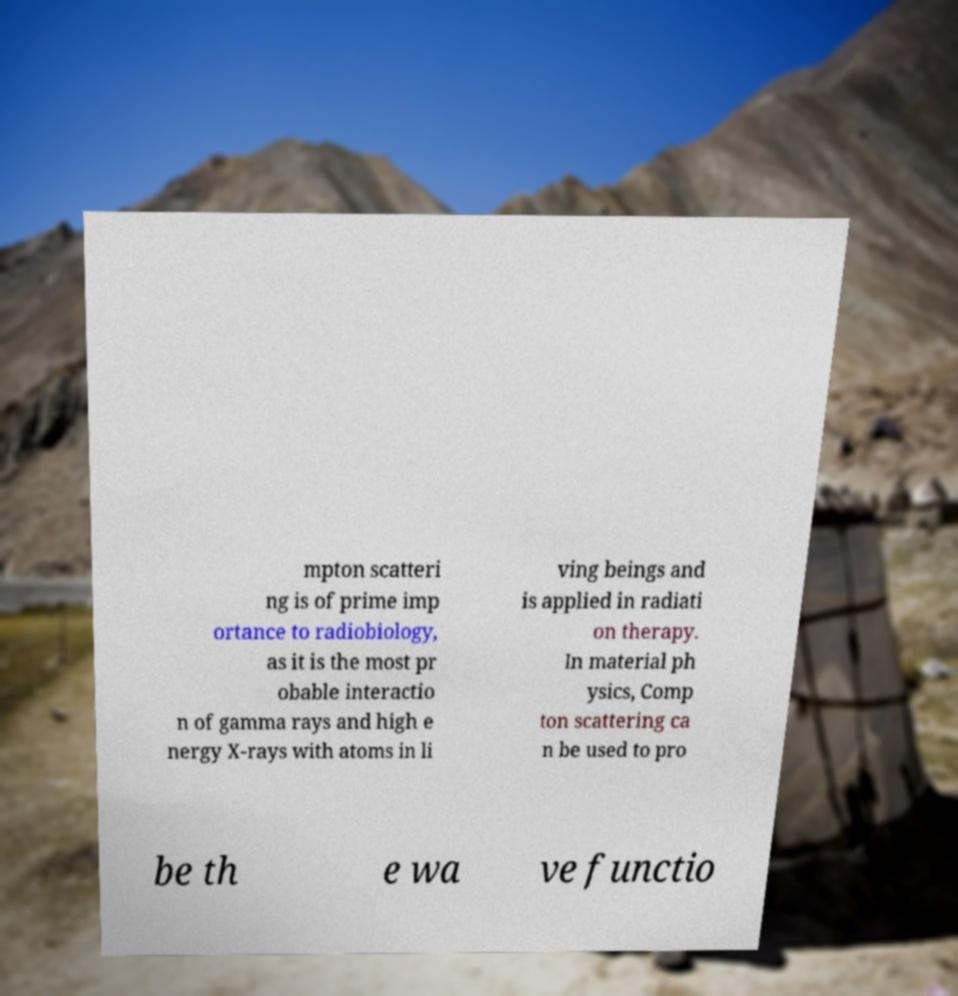Please read and relay the text visible in this image. What does it say? mpton scatteri ng is of prime imp ortance to radiobiology, as it is the most pr obable interactio n of gamma rays and high e nergy X-rays with atoms in li ving beings and is applied in radiati on therapy. In material ph ysics, Comp ton scattering ca n be used to pro be th e wa ve functio 